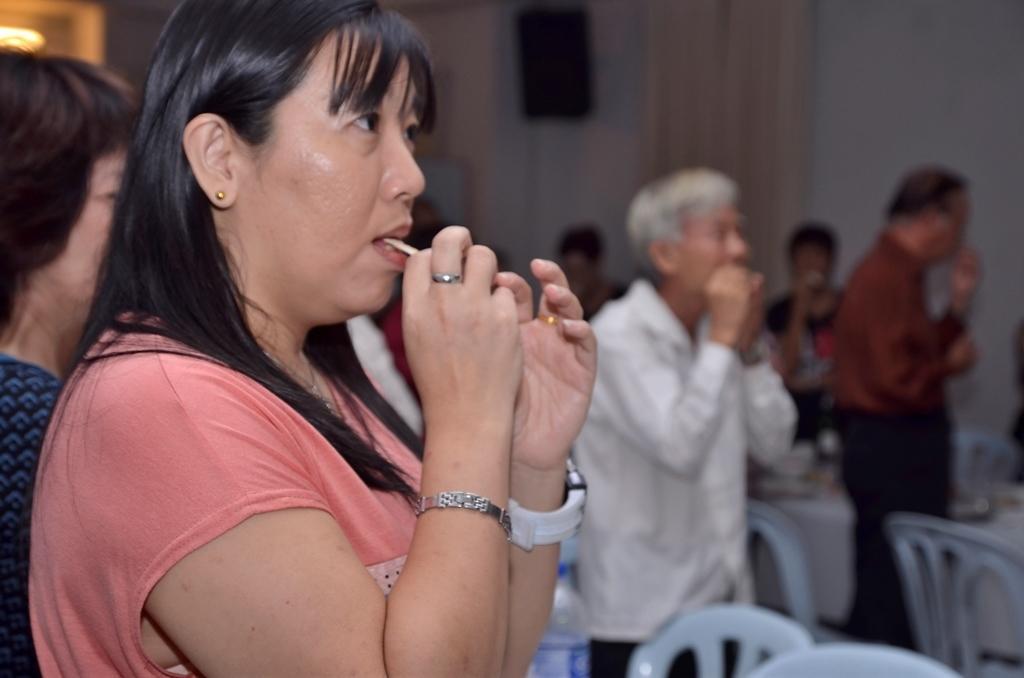Describe this image in one or two sentences. In this image we can see a few people, a lady is eating a food item, there are chairs, table, there is a light, also we can see the wall, and the background is blurred. 